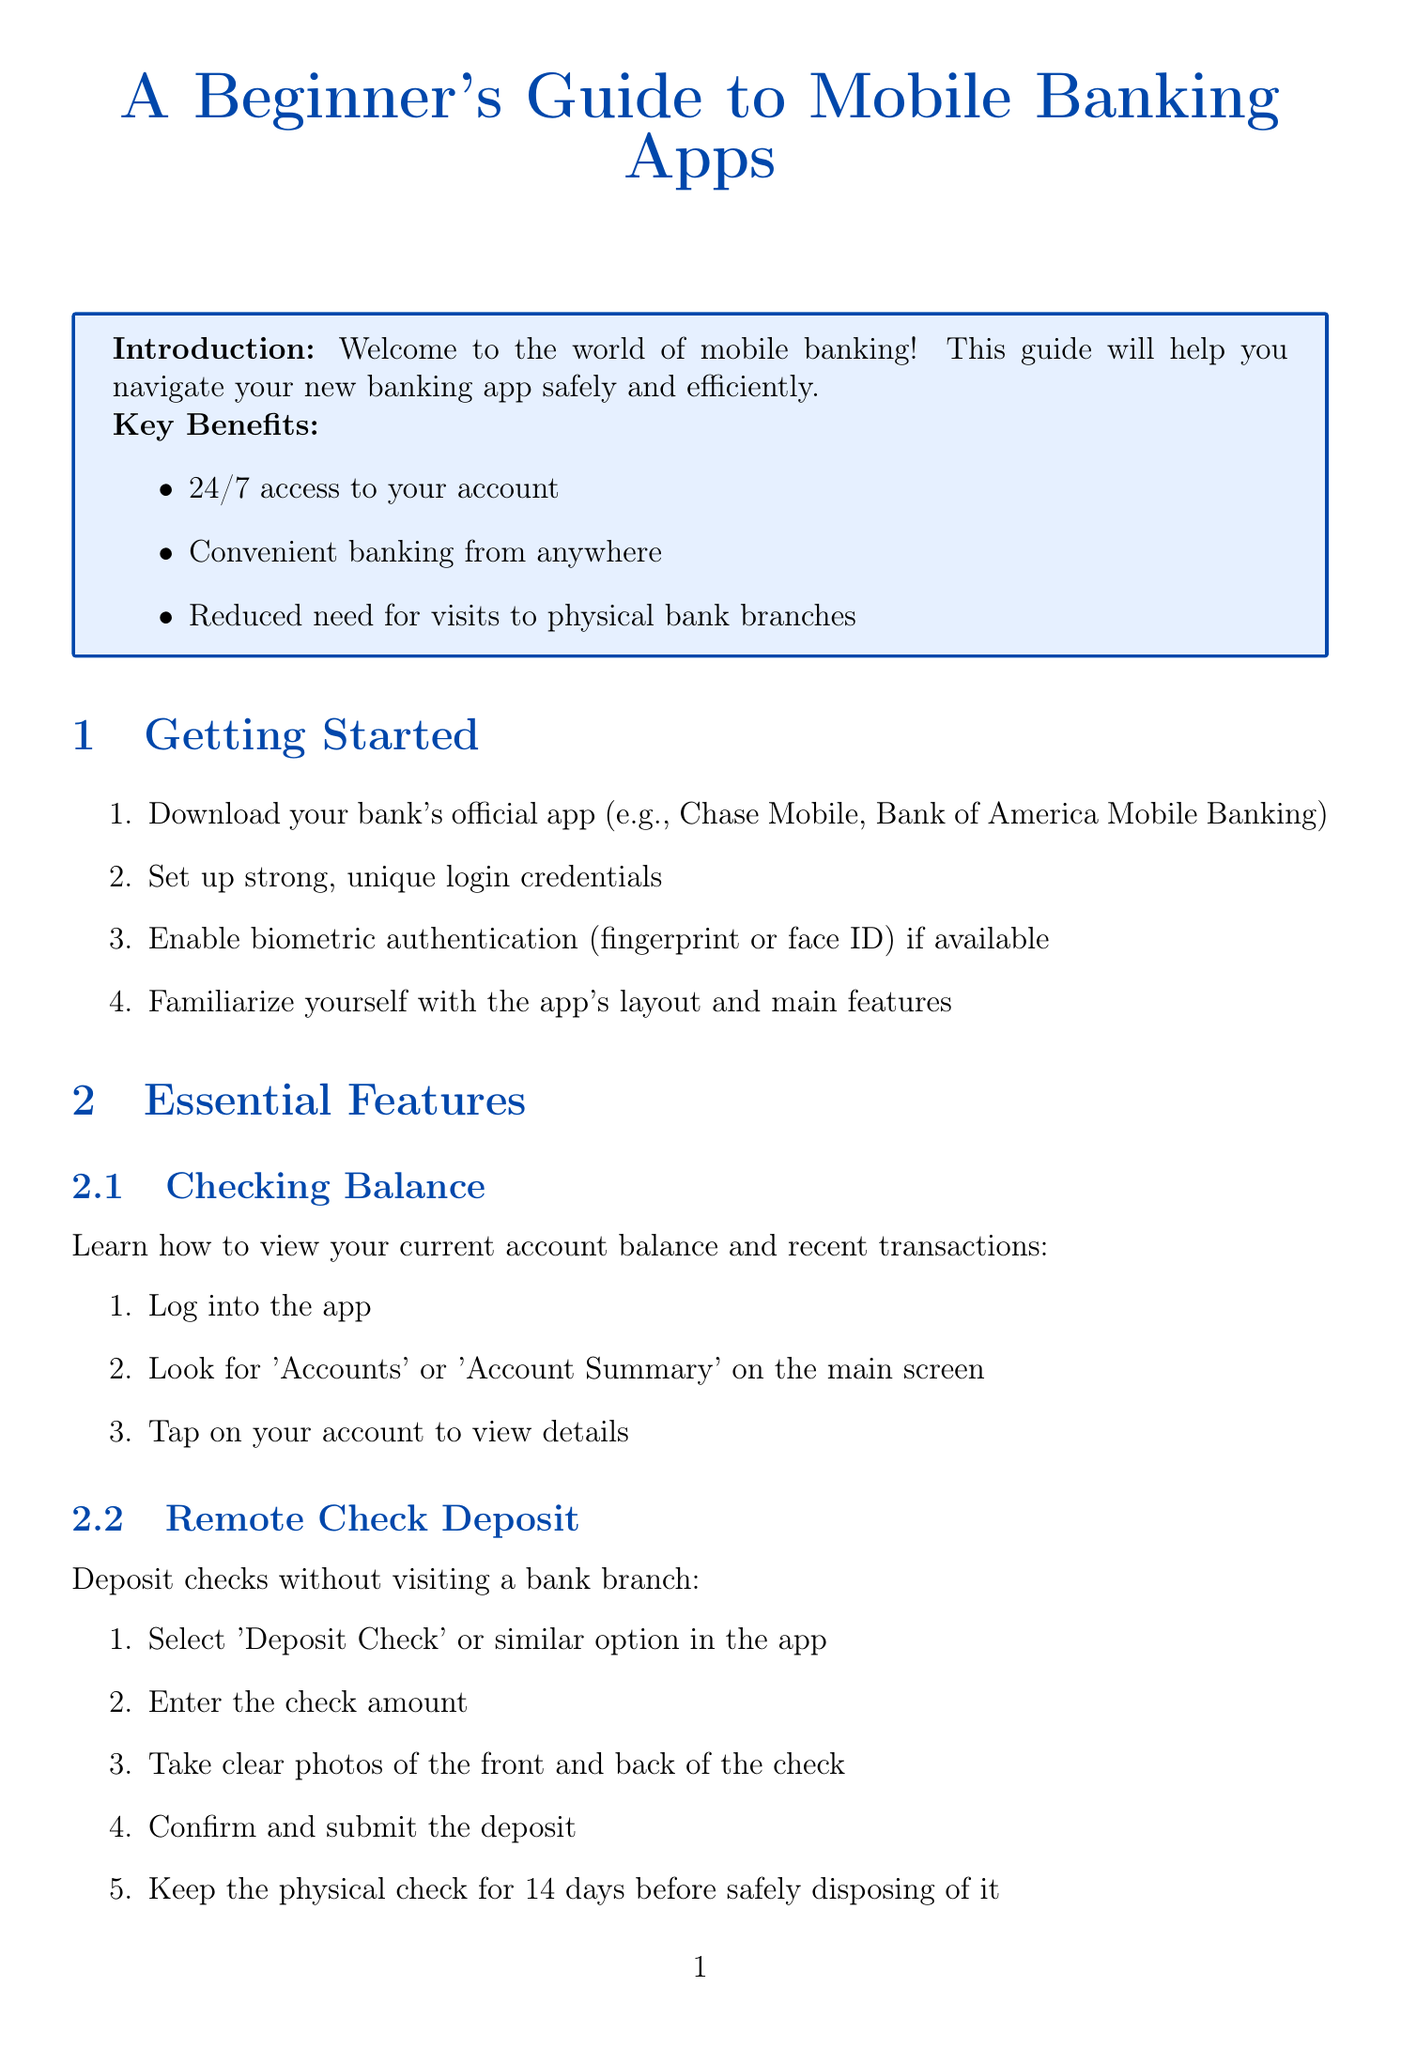what is the title of the document? The title is presented at the top of the document, clearly stating the subject matter.
Answer: A Beginner's Guide to Mobile Banking Apps how many key benefits are listed in the introduction? The introduction section specifies that there are three key benefits provided.
Answer: 3 what should you do after taking photos of a check for remote deposit? The remote check deposit section outlines steps to follow after capturing images of the check.
Answer: Confirm and submit the deposit what types of alerts can you set up in the banking app? The document mentions specific categories for alerts that can be configured by users.
Answer: Low balance alerts, Large transaction alerts, Suspicious activity alerts what is one best practice for banking app security? The security measures section includes several recommendations for safe banking app usage.
Answer: Use a strong, unique password what action should be taken if suspicious activity is detected? The document provides steps to take if a user suspects unauthorized activity in their account.
Answer: Immediately contact your bank's customer service how should you dispose of a physical check after depositing it remotely? The instructions for remote check deposit include guidelines for handling physical checks post-deposit.
Answer: Safely disposing of it after 14 days where can you find the steps to check your current account balance? The essential features section contains instructions specifically related to checking your balance.
Answer: Checking Balance what should be done if you forgot your password? The common issues section offers a solution for a specific problem related to accessing the banking app.
Answer: Use the 'Forgot Password' option 